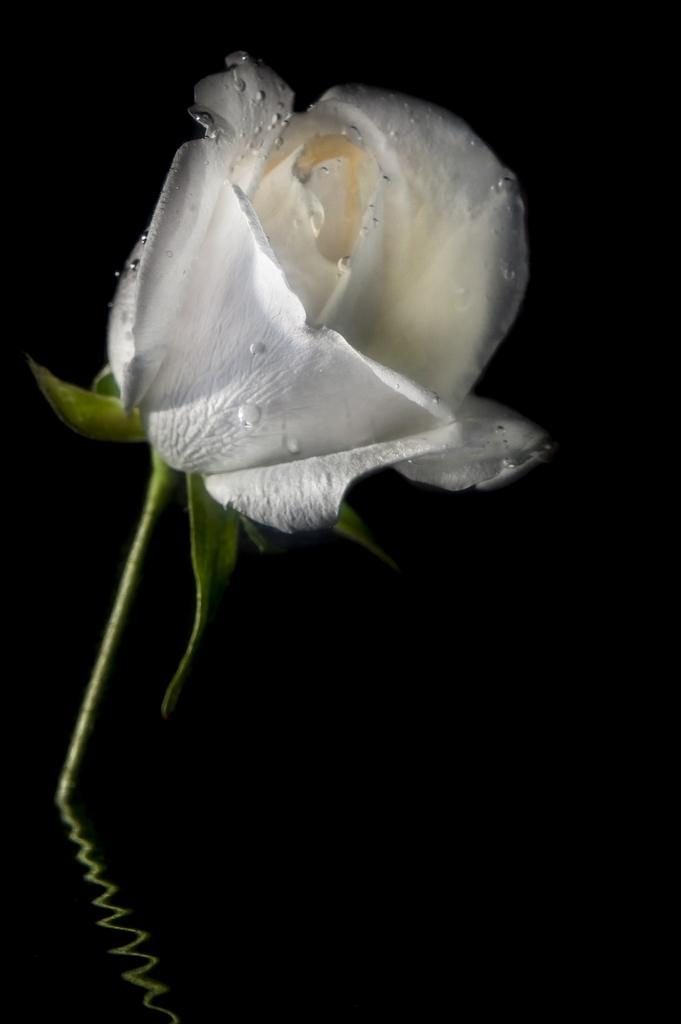What is the main subject of the image? The main subject of the image is water. What is located in the water? There is a white rose in the water. What type of muscle can be seen flexing in the image? There is no muscle visible in the image; it features water with a white rose. What is the toothbrush used for in the image? There is no toothbrush present in the image. 